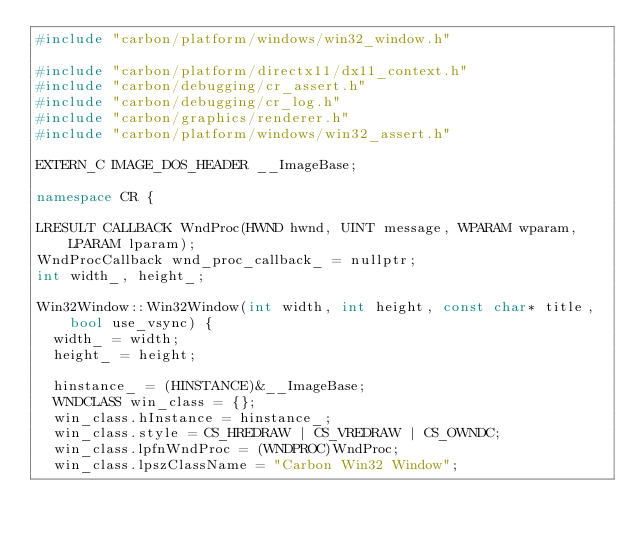Convert code to text. <code><loc_0><loc_0><loc_500><loc_500><_C++_>#include "carbon/platform/windows/win32_window.h"

#include "carbon/platform/directx11/dx11_context.h"
#include "carbon/debugging/cr_assert.h"
#include "carbon/debugging/cr_log.h"
#include "carbon/graphics/renderer.h"
#include "carbon/platform/windows/win32_assert.h"

EXTERN_C IMAGE_DOS_HEADER __ImageBase;

namespace CR {

LRESULT CALLBACK WndProc(HWND hwnd, UINT message, WPARAM wparam, LPARAM lparam);
WndProcCallback wnd_proc_callback_ = nullptr;
int width_, height_;

Win32Window::Win32Window(int width, int height, const char* title, bool use_vsync) {
	width_ = width;
	height_ = height;

  hinstance_ = (HINSTANCE)&__ImageBase;
	WNDCLASS win_class = {};
	win_class.hInstance = hinstance_;
	win_class.style = CS_HREDRAW | CS_VREDRAW | CS_OWNDC;
	win_class.lpfnWndProc = (WNDPROC)WndProc;
	win_class.lpszClassName = "Carbon Win32 Window";</code> 